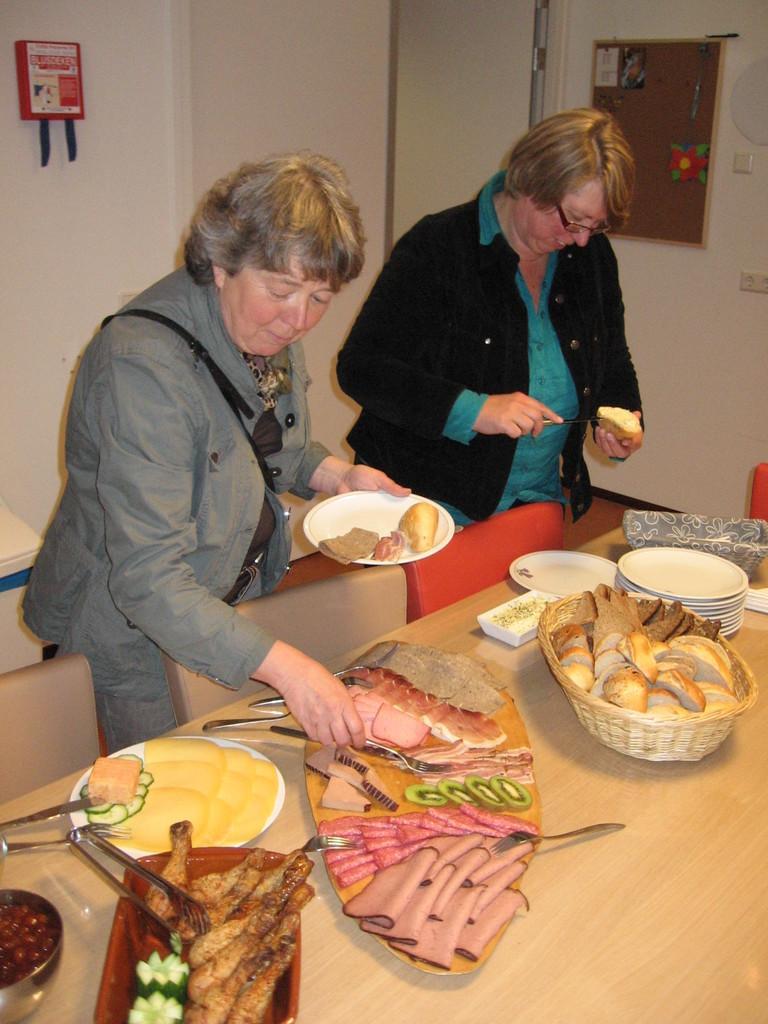How would you summarize this image in a sentence or two? In this picture we can see two women standing here, a woman on the left side is holding a plate, there are three chairs and a table here, we can see plates, a tray present on the table, in the background there is a wall, we can see some food and a fork here. 